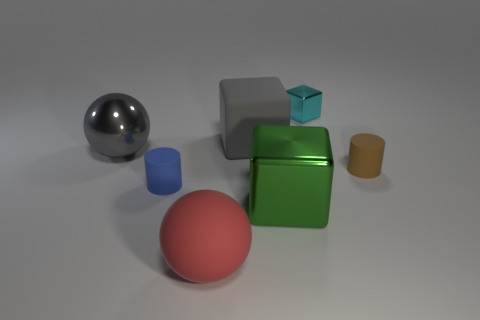Subtract 1 balls. How many balls are left? 1 Subtract all green metal cubes. How many cubes are left? 2 Add 1 small cyan blocks. How many objects exist? 8 Subtract all gray blocks. How many blocks are left? 2 Subtract all small blocks. Subtract all small green metal cylinders. How many objects are left? 6 Add 7 cubes. How many cubes are left? 10 Add 4 cylinders. How many cylinders exist? 6 Subtract 0 brown spheres. How many objects are left? 7 Subtract all cubes. How many objects are left? 4 Subtract all green spheres. Subtract all cyan blocks. How many spheres are left? 2 